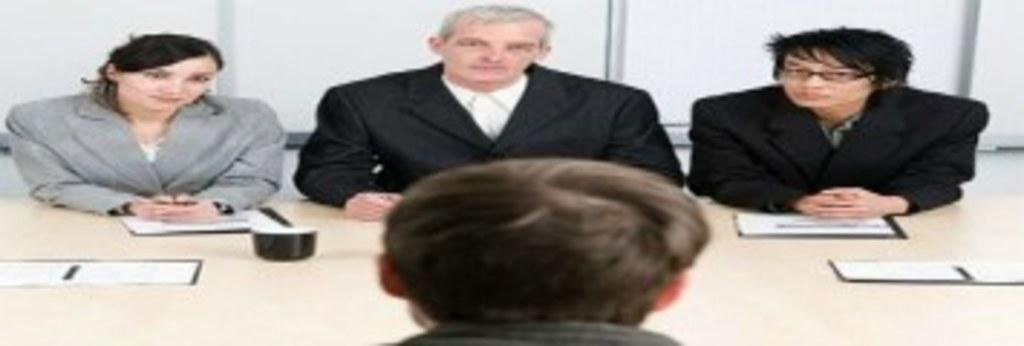How many people are in the image? There are four persons in the image. What is located in front of the persons? There is a table in front of the persons. What can be seen on the table? Papers are present on the table. What type of straw is being used by the woman in the image? There is no woman or straw present in the image. How many passengers are visible in the image? There is no reference to passengers in the image; it features four persons. 